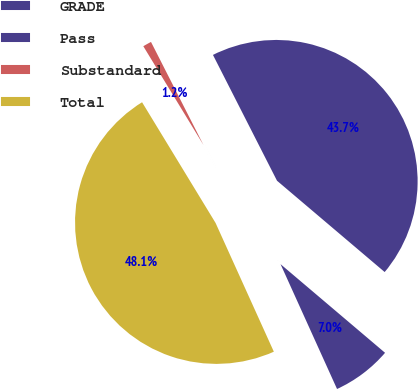Convert chart. <chart><loc_0><loc_0><loc_500><loc_500><pie_chart><fcel>GRADE<fcel>Pass<fcel>Substandard<fcel>Total<nl><fcel>7.04%<fcel>43.69%<fcel>1.21%<fcel>48.06%<nl></chart> 